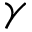Convert formula to latex. <formula><loc_0><loc_0><loc_500><loc_500>\gamma</formula> 